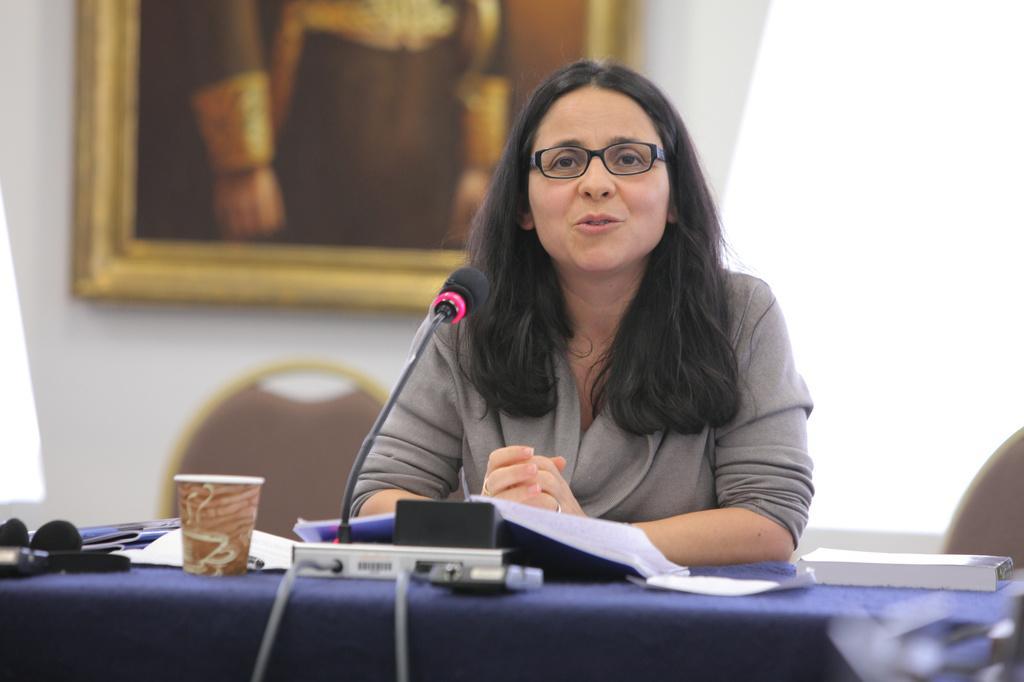In one or two sentences, can you explain what this image depicts? In this image there is a woman sitting in front of the table with mic, glass, books, papers and a few other objects on it, behind her there are chairs and a frame is hanging on the wall. 